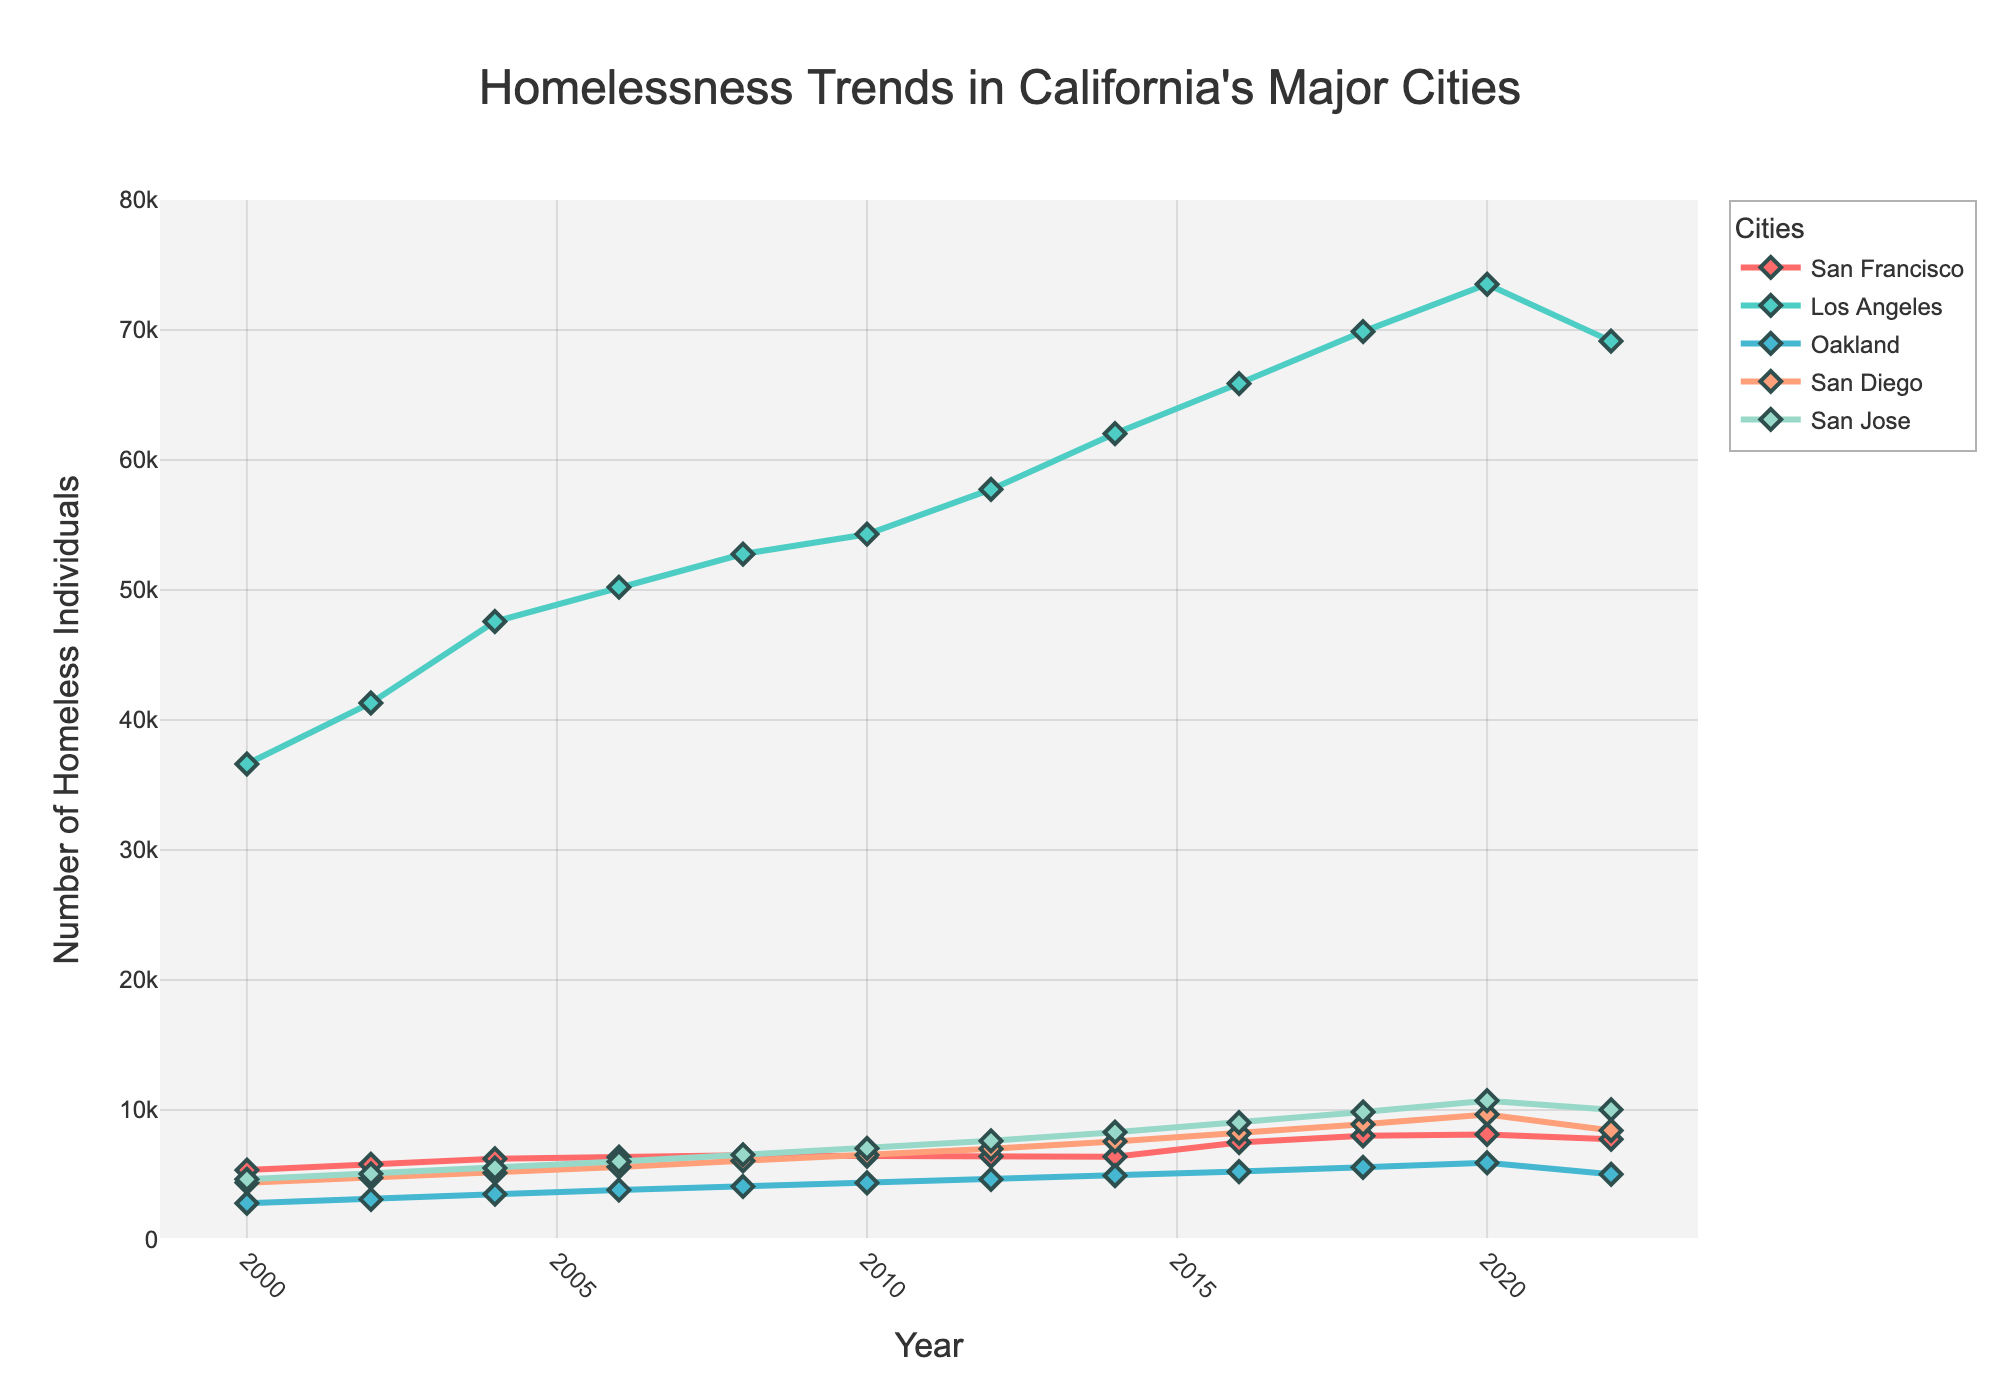What is the trend of homelessness in Oakland from 2000 to 2022? The data shows the number of homeless individuals in Oakland from 2000 to 2022 at different intervals. By plotting these values on a line chart, we can observe whether the trend is increasing, decreasing, or stable. The numbers in Oakland generally show an increasing trend from 2829 in 2000 to 5055 in 2022, with some fluctuations.
Answer: Increasing Which city had the highest number of homeless individuals in 2020? To find this, look at the line peaks for 2020 on the chart and identify which city's data point is the highest. In 2020, Los Angeles had the highest with 73523 homeless individuals.
Answer: Los Angeles By how much did the number of homeless individuals in San Francisco increase from 2000 to 2018? Subtract the number of homeless individuals in San Francisco in 2000 from the number in 2018. This is 8011 (in 2018) - 5376 (in 2000) = 2635.
Answer: 2635 Which cities experienced a decrease in homelessness between 2020 and 2022? Compare the values for each city in 2020 and in 2022. San Francisco, Los Angeles, Oakland, and San Diego show a decrease in numbers from 2020 to 2022.
Answer: San Francisco, Los Angeles, Oakland, San Diego What is the average number of homeless individuals in Oakland across all the years presented? Sum all the homelessness numbers for Oakland from 2000 to 2022 and divide by the number of years (12). (2829 + 3123 + 3525 + 3848 + 4117 + 4395 + 4670 + 4957 + 5263 + 5589 + 5937 + 5055) / 12 = 4401.92, approximately 4402.
Answer: 4402 Compare the homelessness trends between San Jose and San Diego from 2000 to 2022. Which city had a higher growth rate? First, calculate the increase in homelessness for both cities from 2000 to 2022. San Diego goes from 4413 to 8427, an increase of 4014. San Jose goes from 4668 to 10028, an increase of 5360. San Jose had a higher growth rate.
Answer: San Jose Which city's homelessness trend saw the most significant increase from 2006 to 2016? Check the values for all cities in 2006 and 2016, and compute the increase for each. San Francisco increased from 6377 in 2006 to 7499 in 2016, an increase of 1122. Los Angeles increased from 50214 to 65881, an increase of 15667. Oakland increased from 3848 to 5263, an increase of 1415. San Diego increased from 5619 to 8207, an increase of 2588. San Jose increased from 6030 to 9030, an increase of 3000. Los Angeles had the most significant increase.
Answer: Los Angeles By what percentage did homelessness increase in San Jose from 2000 to 2020? Calculate the percentage increase using the formula: (final value - initial value) / initial value * 100. For San Jose, (10720 - 4668) / 4668 * 100 = 129.6%.
Answer: 129.6% What can be inferred about the trend of homelessness in Los Angeles between 2008 and 2022? By observing the chart, we can see an increase in the number of homeless individuals from 52765 in 2008 to a peak of 73523 in 2020 followed by a slight decrease to 69144 in 2022.
Answer: It increased and then slightly decreased In which year did Oakland's homelessness surpass San Francisco's? Compare the values of Oakland and San Francisco year by year. Oakland's homelessness first surpasses San Francisco in 2022, where Oakland has 5055 and San Francisco has 7754.
Answer: 2022 